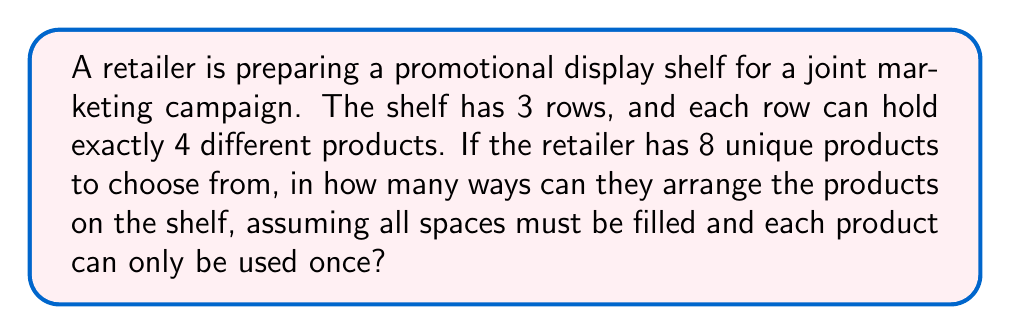Can you solve this math problem? Let's approach this step-by-step:

1) First, we need to choose which products will go on the shelf. We need to select 12 products (3 rows × 4 products per row) out of 8 available products.

2) This is actually a permutation problem, not a combination, because the order matters (we're arranging the products, not just selecting them).

3) The number of ways to arrange 12 products out of 8 is given by the permutation formula:

   $$P(8,12) = \frac{8!}{(8-12)!} = \frac{8!}{-4!}$$

4) However, since 12 > 8, this permutation is not possible. We can't arrange 12 products when we only have 8 unique products available.

5) Instead, we need to use all 8 products and arrange them in the 12 spaces.

6) This is a straightforward permutation of 8 items:

   $$P(8,8) = 8! = 8 \times 7 \times 6 \times 5 \times 4 \times 3 \times 2 \times 1 = 40,320$$

7) Therefore, there are 40,320 ways to arrange the 8 products in the 12 spaces on the shelf.
Answer: 40,320 